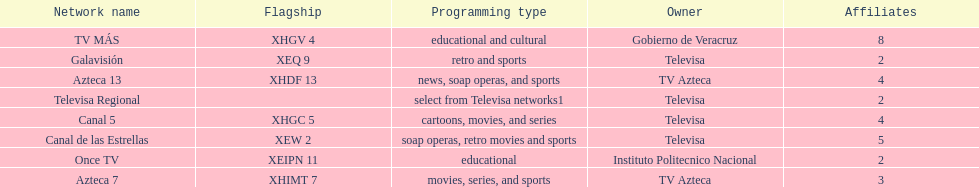Name each of tv azteca's network names. Azteca 7, Azteca 13. 